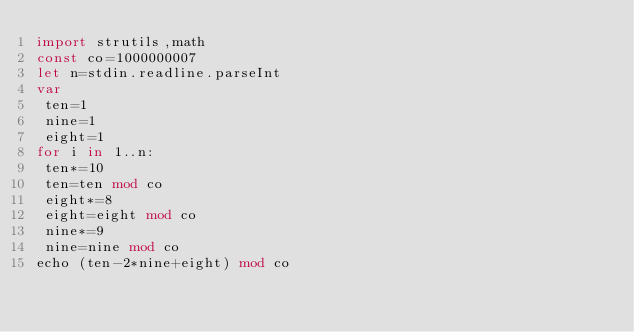Convert code to text. <code><loc_0><loc_0><loc_500><loc_500><_Nim_>import strutils,math
const co=1000000007
let n=stdin.readline.parseInt
var
 ten=1
 nine=1
 eight=1
for i in 1..n:
 ten*=10
 ten=ten mod co
 eight*=8
 eight=eight mod co
 nine*=9
 nine=nine mod co
echo (ten-2*nine+eight) mod co</code> 